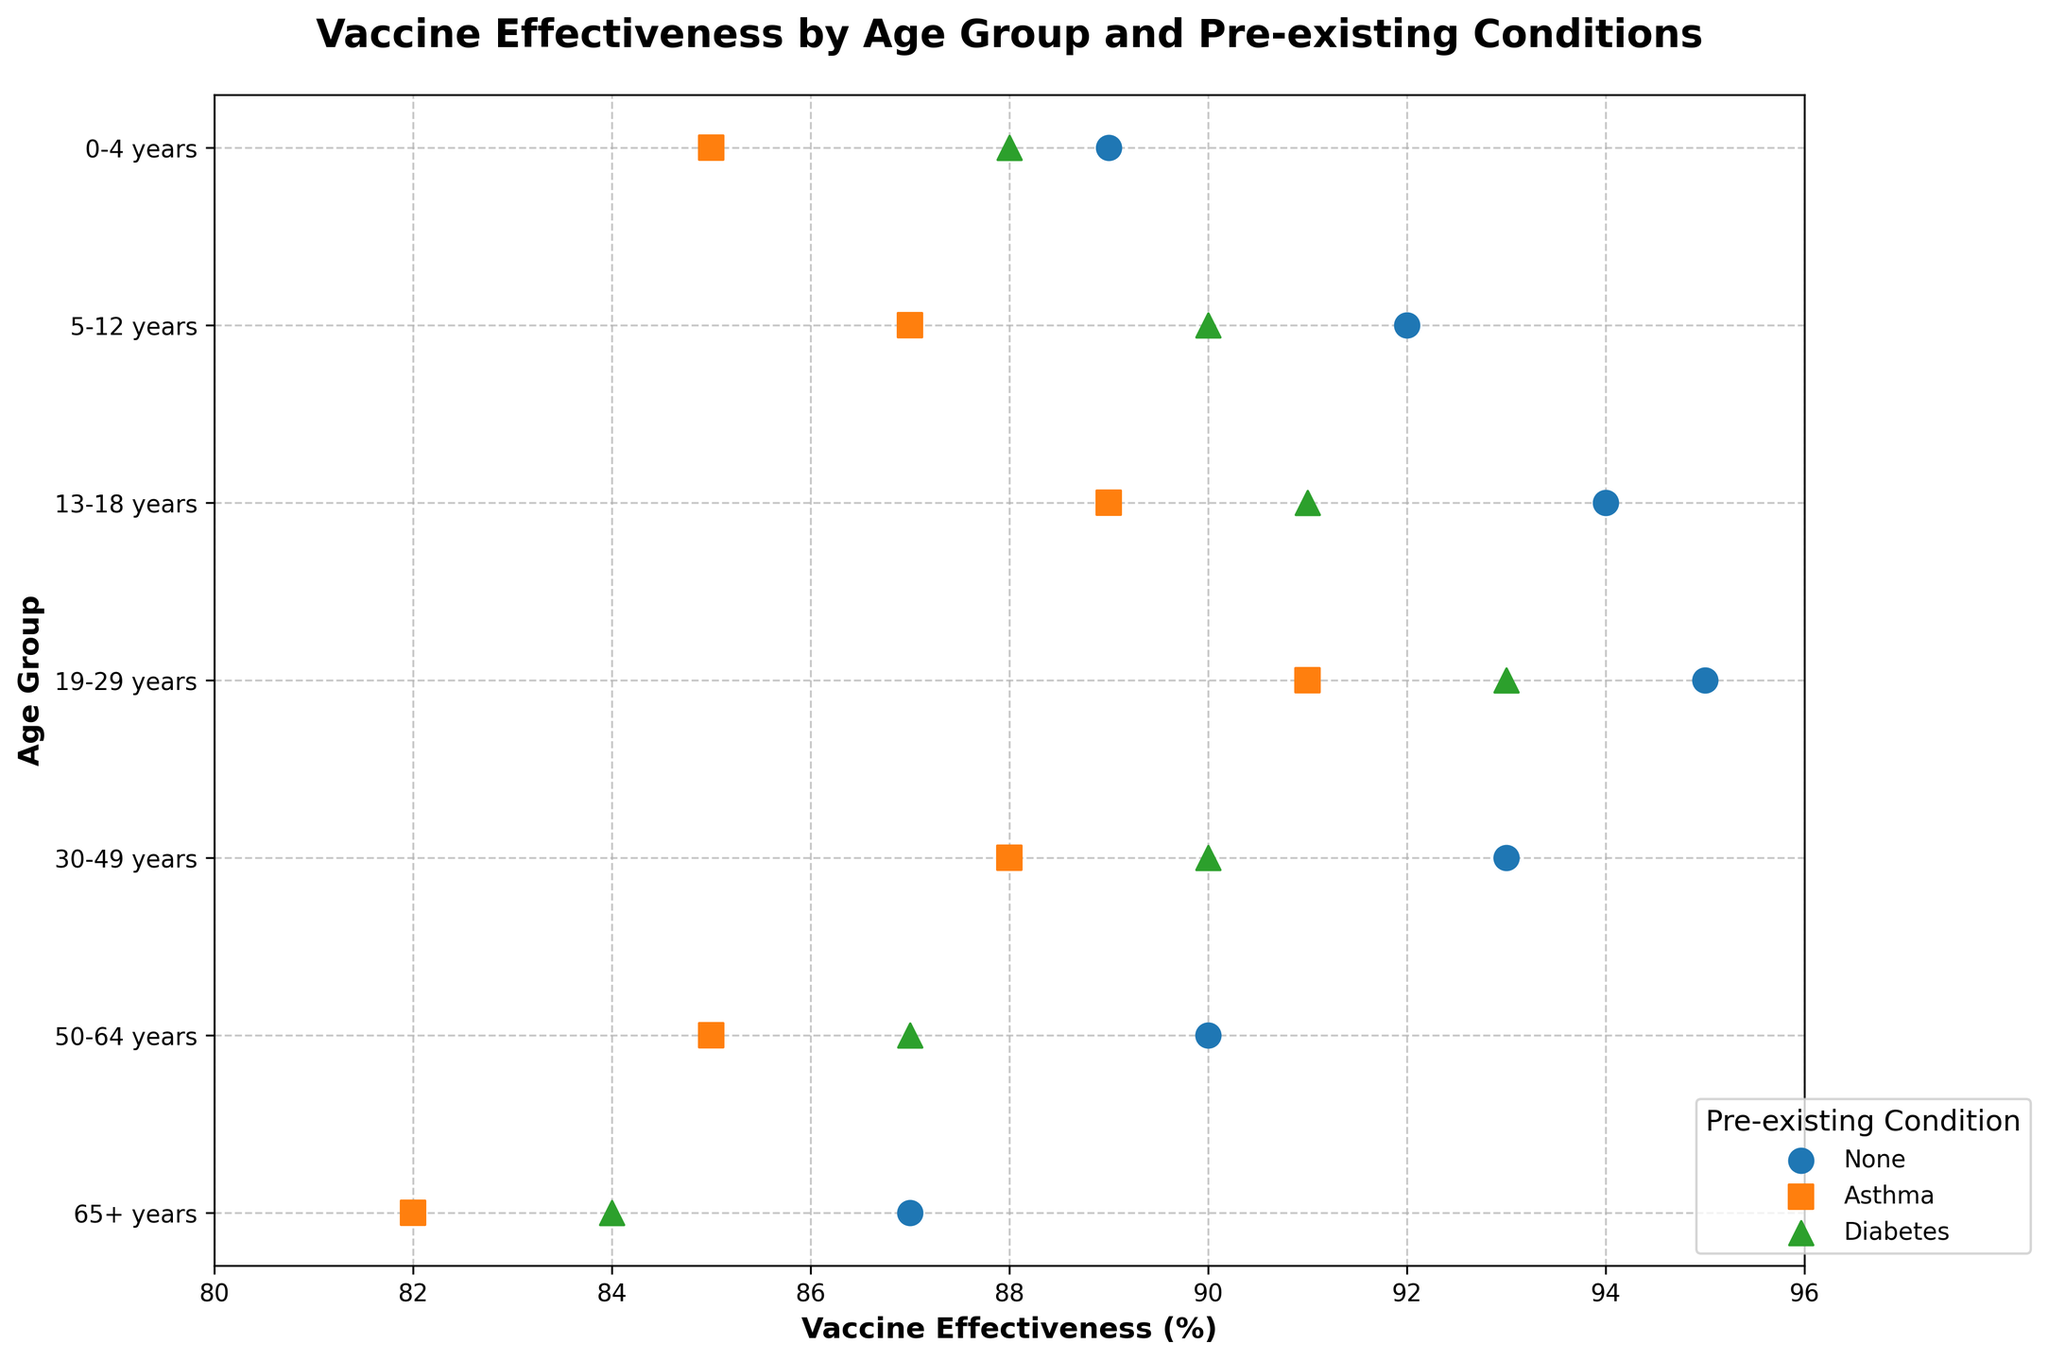What is the title of the figure? The title of the figure is found at the top and summarizes what the plot is about. It reads: 'Vaccine Effectiveness by Age Group and Pre-existing Conditions'
Answer: Vaccine Effectiveness by Age Group and Pre-existing Conditions How many age groups are represented in the plot? Age groups can be identified along the y-axis, typically listed in order. There are 7 age groups: 0-4 years, 5-12 years, 13-18 years, 19-29 years, 30-49 years, 50-64 years, and 65+ years
Answer: 7 What is the effectiveness of the vaccine for the 5-12 years group with asthma? Locate the 5-12 years group along the y-axis and find the point corresponding to asthma, then refer to the x-axis for the vaccine effectiveness value. The effectiveness is shown as 87%
Answer: 87% Which age group with no pre-existing conditions has the highest vaccine effectiveness? Compare all data points with 'None' (no pre-existing conditions) across age groups by looking at their x-axis values, and identify the highest value. The age group 19-29 years has the highest effectiveness at 95%
Answer: 19-29 years What is the difference in vaccine effectiveness between the 0-4 years group with diabetes and the 0-4 years group with no pre-existing conditions? Compare the effectiveness values for these two groups visually: 88% for diabetes and 89% for no conditions. The difference is 89% - 88%.
Answer: 1% Is there any age group where vaccine effectiveness is identical for asthma and diabetes? For each age group, compare the points for asthma and diabetes by checking if their values on the x-axis are the same. For the age group 50-64 years, both asthma and diabetes have effectiveness of 85%.
Answer: 50-64 years What is the average effectiveness of vaccines for the 30-49 years group across all conditions? Identify the effectiveness values for all conditions in the 30-49 years group: 93% (None), 88% (Asthma), and 90% (Diabetes). Calculate the average: (93 + 88 + 90) / 3 = 90.33%
Answer: 90.33% Which age group shows the lowest vaccine effectiveness for those with asthma? Locate the points corresponding to asthma across all age groups and identify the one with the lowest x-axis value. The 65+ years group shows the lowest effectiveness at 82%
Answer: 65+ years How does the vaccine effectiveness for the 13-18 years group with no conditions compare to the 65+ years group with diabetes? Compare the x-axis values for these groups: 13-18 years with no conditions is 94%, and 65+ years with diabetes is 84%. The effectiveness is higher for the 13-18 years group by 10%
Answer: 10% higher for 13-18 years What is the median vaccine effectiveness for the 19-29 years group considering all conditions? List the effectiveness values for the 19-29 years group: 95% (None), 91% (Asthma), 93% (Diabetes). In ascending order: 91%, 93%, 95%. The median value is the middle one, which is 93%
Answer: 93% 